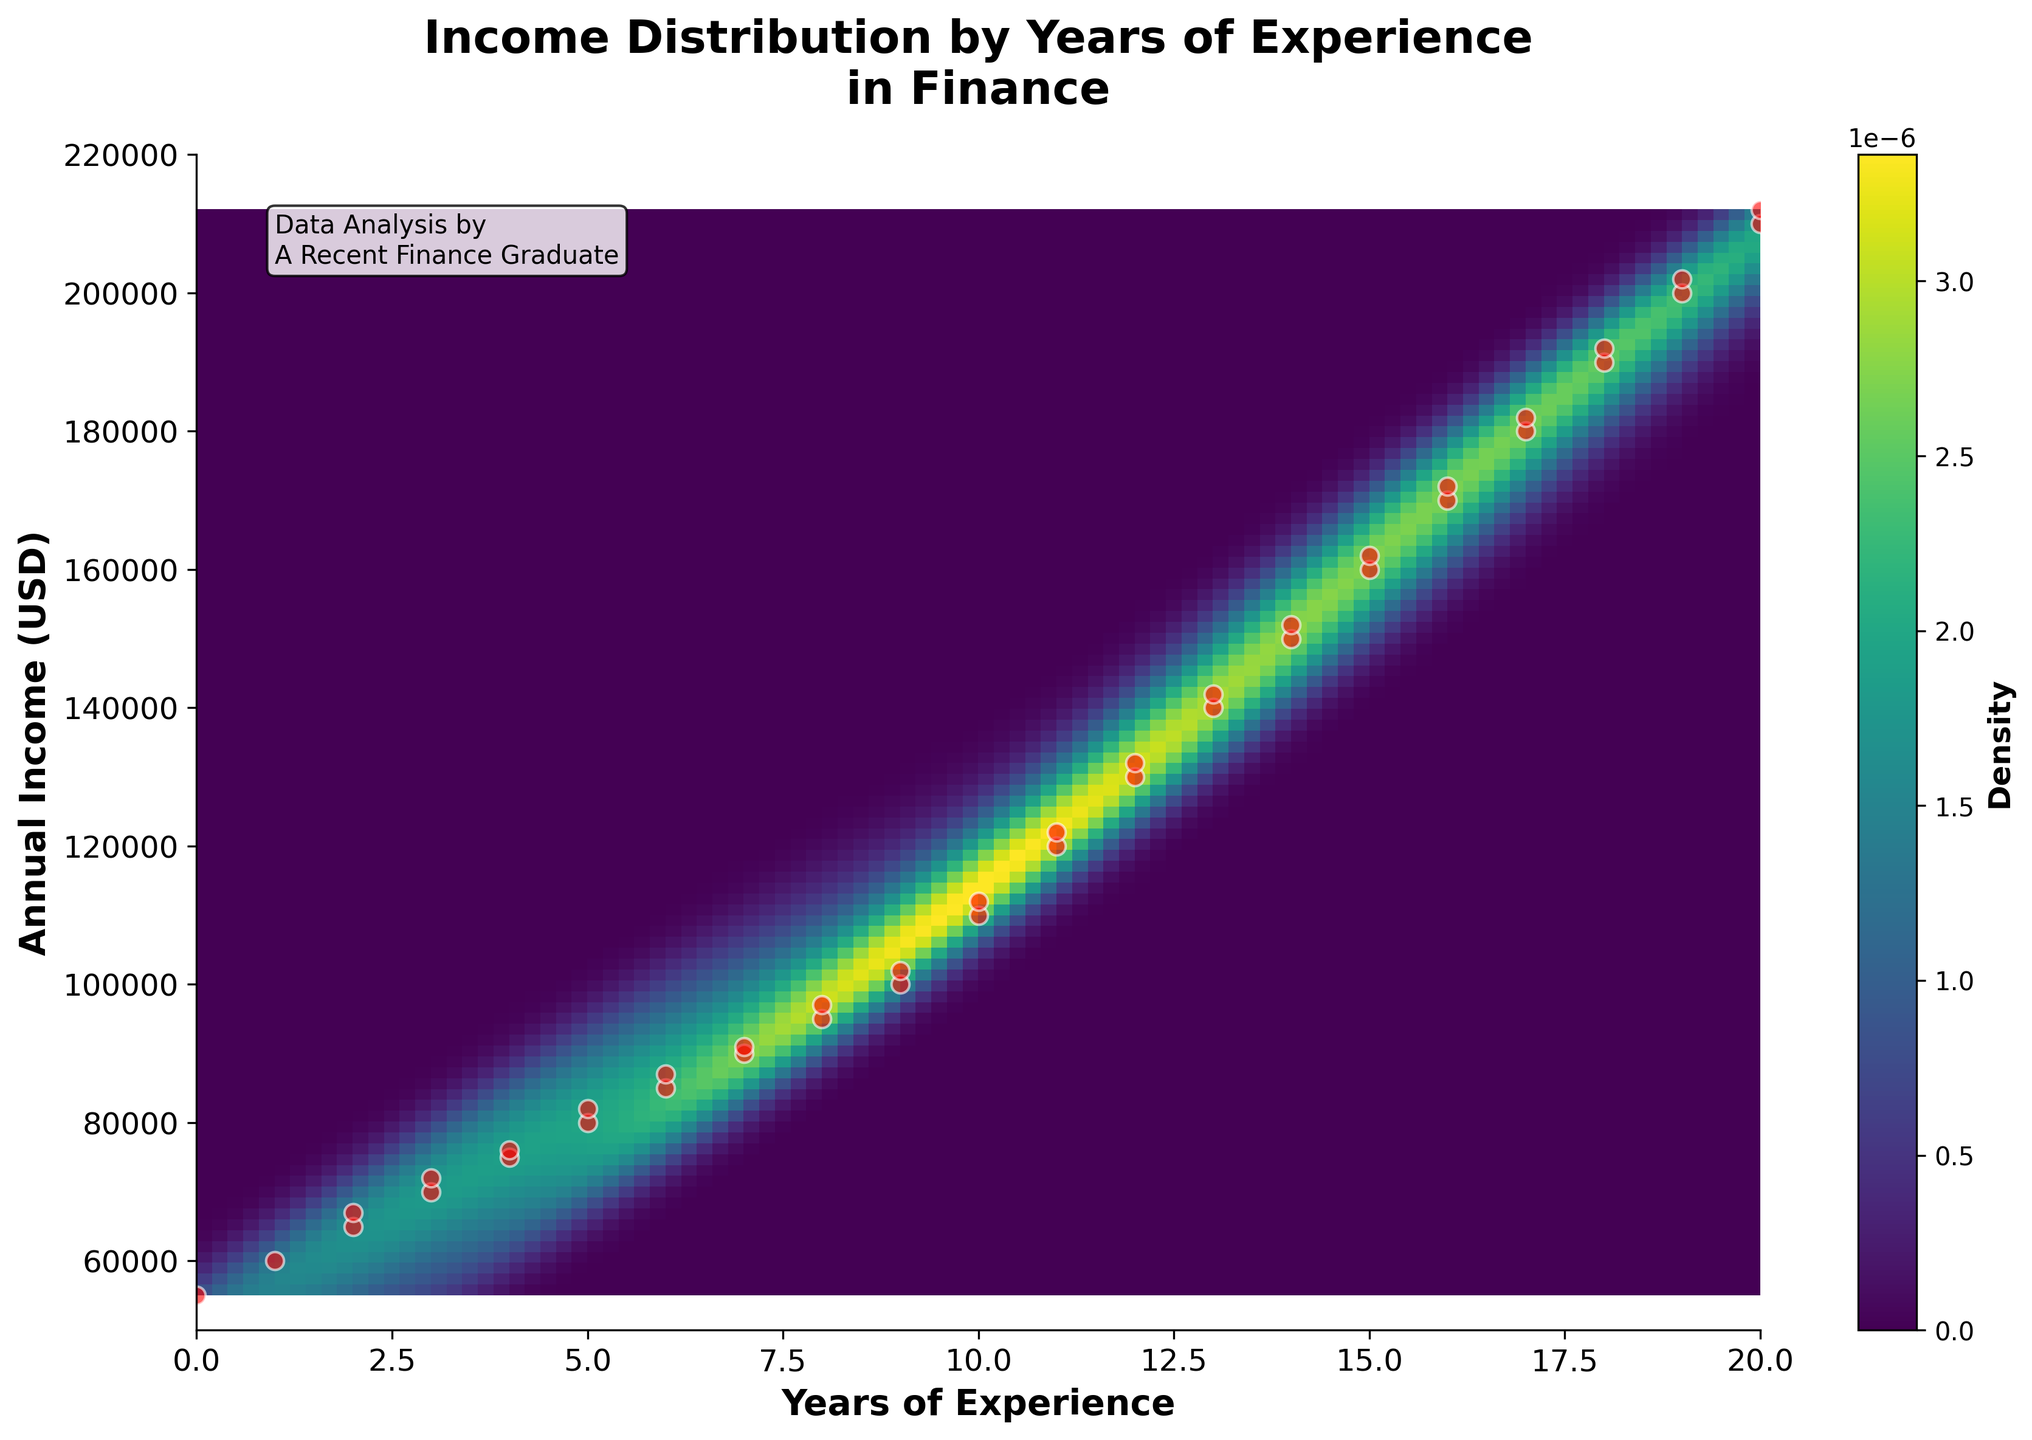What's the title of the chart? The title of the chart is displayed at the top of the plot. It states, "Income Distribution by Years of Experience in Finance".
Answer: Income Distribution by Years of Experience in Finance What do the x-axis and y-axis represent? The x-axis represents the 'Years of Experience', and the y-axis represents the 'Annual Income (USD)' of finance professionals. These labels are clearly indicated at their respective axis locations.
Answer: Years of Experience and Annual Income (USD) How many data points are shown in the scatter plot? To count the number of data points, we need to count each red dot on the scatter plot. Given that there are 41 pairs of coordinates in the data, this results in 41 red dots representing each data point.
Answer: 41 What is the highest annual income in the data set? By examining the y-axis and identifying the highest red dot on the scatter plot, we can see that the highest annual income is around 212,000 USD. This value also matches the data provided.
Answer: 212,000 USD At approximately how many years of experience does the highest density of income occur? The highest density regions are indicated by the areas with the most intense color (e.g., the darkest area). This appears around 12 to 13 years of experience on the x-axis.
Answer: 12-13 years of experience Compare the income of someone with 10 years of experience and someone with 15 years of experience. Who typically earns more? Refer to the y-values corresponding to 10 and 15 years on the x-axis. The dots at these x-values indicate that the annual income at 15 years (approximately 160,000-162,000 USD) is higher than at 10 years (approximately 110,000-112,000 USD).
Answer: 15 years of experience Between 5 and 10 years of experience, what is the general trend in income distribution? Observing the scatter plot and density colors between 5 and 10 years, it shows an ascending trend. The density also appears to show increasing values from around 80,000 USD at 5 years to over 110,000 USD at 10 years.
Answer: Increasing trend What color represents the highest density in the density plot? The color representing the highest density in the plot is the darkest shade of green, which appears almost black in the 'viridis' colormap used.
Answer: Dark green (almost black) Is there any noticeable outlier in the income data for low years of experience? Scanning the scatter plot on the left side of the x-axis for outliers in income, no significant deviations from the pattern are present. However, the incomes appear to start lower and uniformly increase without significant outliers.
Answer: No Which range of years of experience generally exhibits an annual income of around 200,000 USD? Identify the annual income mark around 200,000 USD on the y-axis and look for nearby red dots on the x-axis. This occurs between about 18 to 20 years of experience.
Answer: 18-20 years of experience 